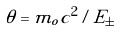<formula> <loc_0><loc_0><loc_500><loc_500>\theta = m _ { o } c ^ { 2 } / E _ { \pm }</formula> 